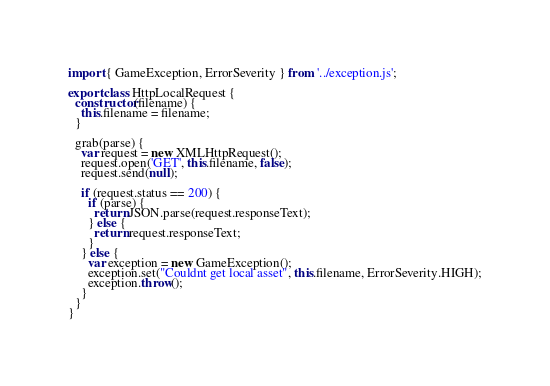<code> <loc_0><loc_0><loc_500><loc_500><_JavaScript_>
import { GameException, ErrorSeverity } from '../exception.js';

export class HttpLocalRequest {
  constructor(filename) {
    this.filename = filename;
  }

  grab(parse) {
    var request = new XMLHttpRequest();
    request.open('GET', this.filename, false);
    request.send(null);
    
    if (request.status == 200) {
      if (parse) {
        return JSON.parse(request.responseText);
      } else {
        return request.responseText;
      }
    } else {
      var exception = new GameException();
      exception.set("Couldnt get local asset", this.filename, ErrorSeverity.HIGH);
      exception.throw();
    }
  }
}
</code> 